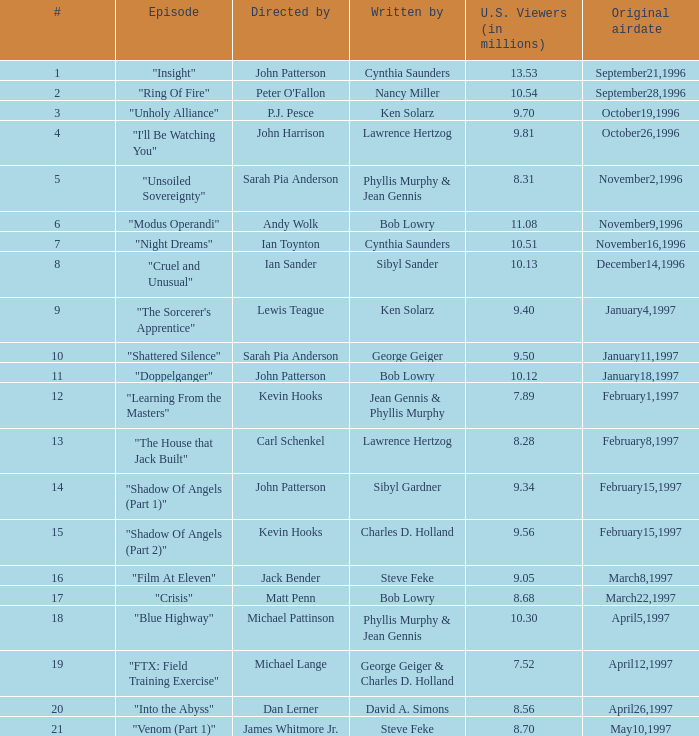52 million us viewers? George Geiger & Charles D. Holland. 